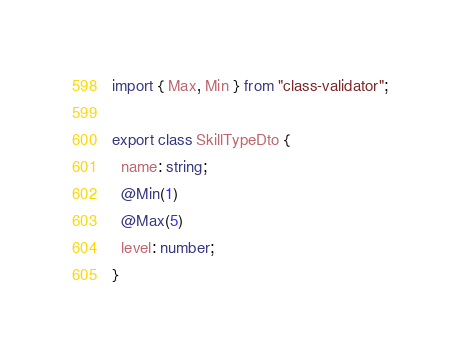Convert code to text. <code><loc_0><loc_0><loc_500><loc_500><_TypeScript_>import { Max, Min } from "class-validator";

export class SkillTypeDto {
  name: string;
  @Min(1)
  @Max(5)
  level: number;
}


</code> 